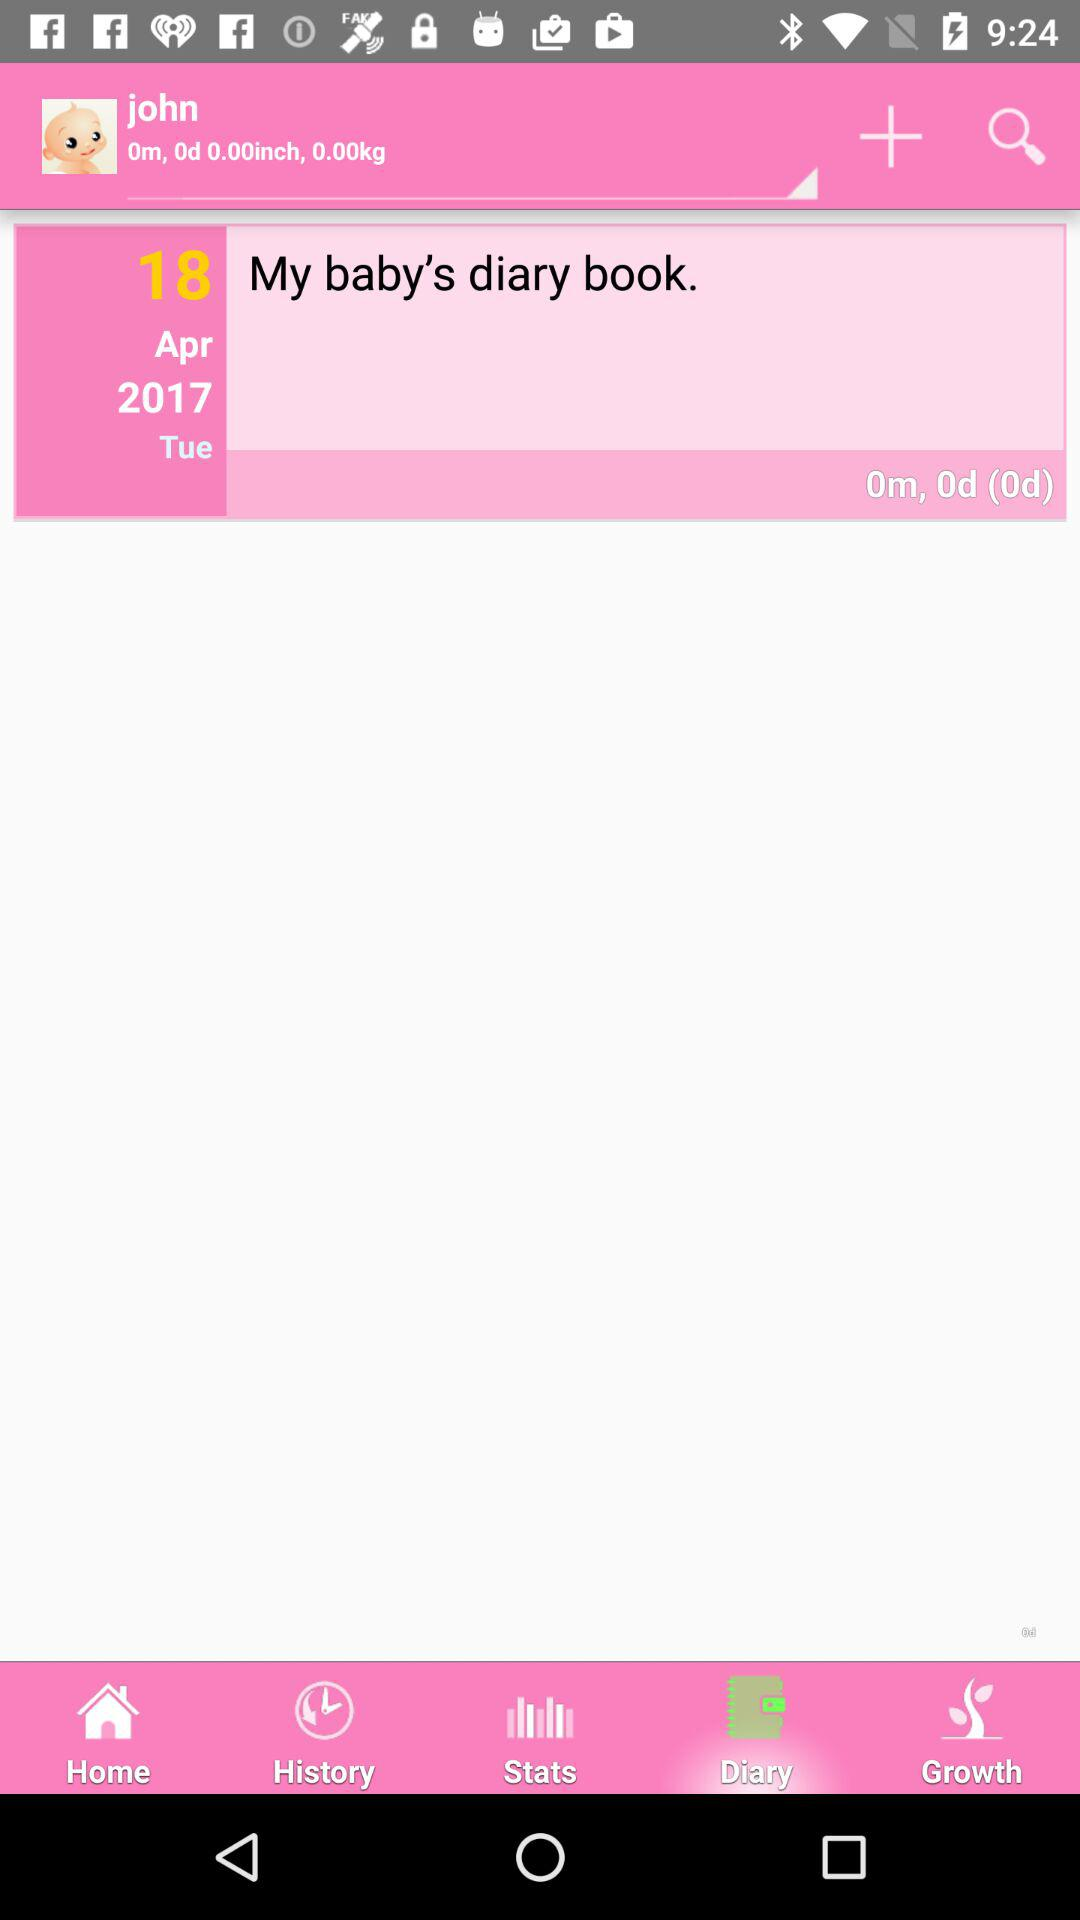How many days old is the baby?
Answer the question using a single word or phrase. 0d 